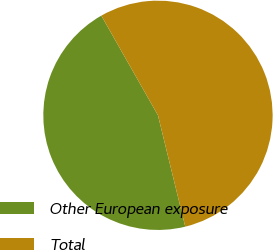<chart> <loc_0><loc_0><loc_500><loc_500><pie_chart><fcel>Other European exposure<fcel>Total<nl><fcel>45.6%<fcel>54.4%<nl></chart> 